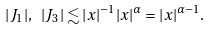Convert formula to latex. <formula><loc_0><loc_0><loc_500><loc_500>| J _ { 1 } | , \ | J _ { 3 } | \lesssim | x | ^ { - 1 } | x | ^ { \alpha } = | x | ^ { \alpha - 1 } .</formula> 